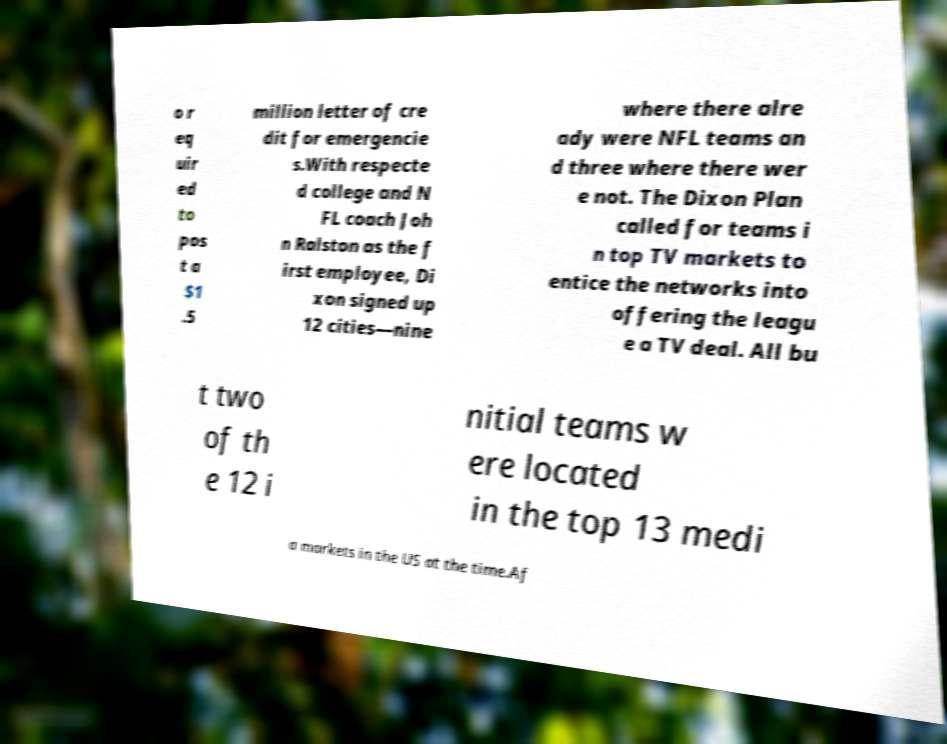There's text embedded in this image that I need extracted. Can you transcribe it verbatim? o r eq uir ed to pos t a $1 .5 million letter of cre dit for emergencie s.With respecte d college and N FL coach Joh n Ralston as the f irst employee, Di xon signed up 12 cities—nine where there alre ady were NFL teams an d three where there wer e not. The Dixon Plan called for teams i n top TV markets to entice the networks into offering the leagu e a TV deal. All bu t two of th e 12 i nitial teams w ere located in the top 13 medi a markets in the US at the time.Af 